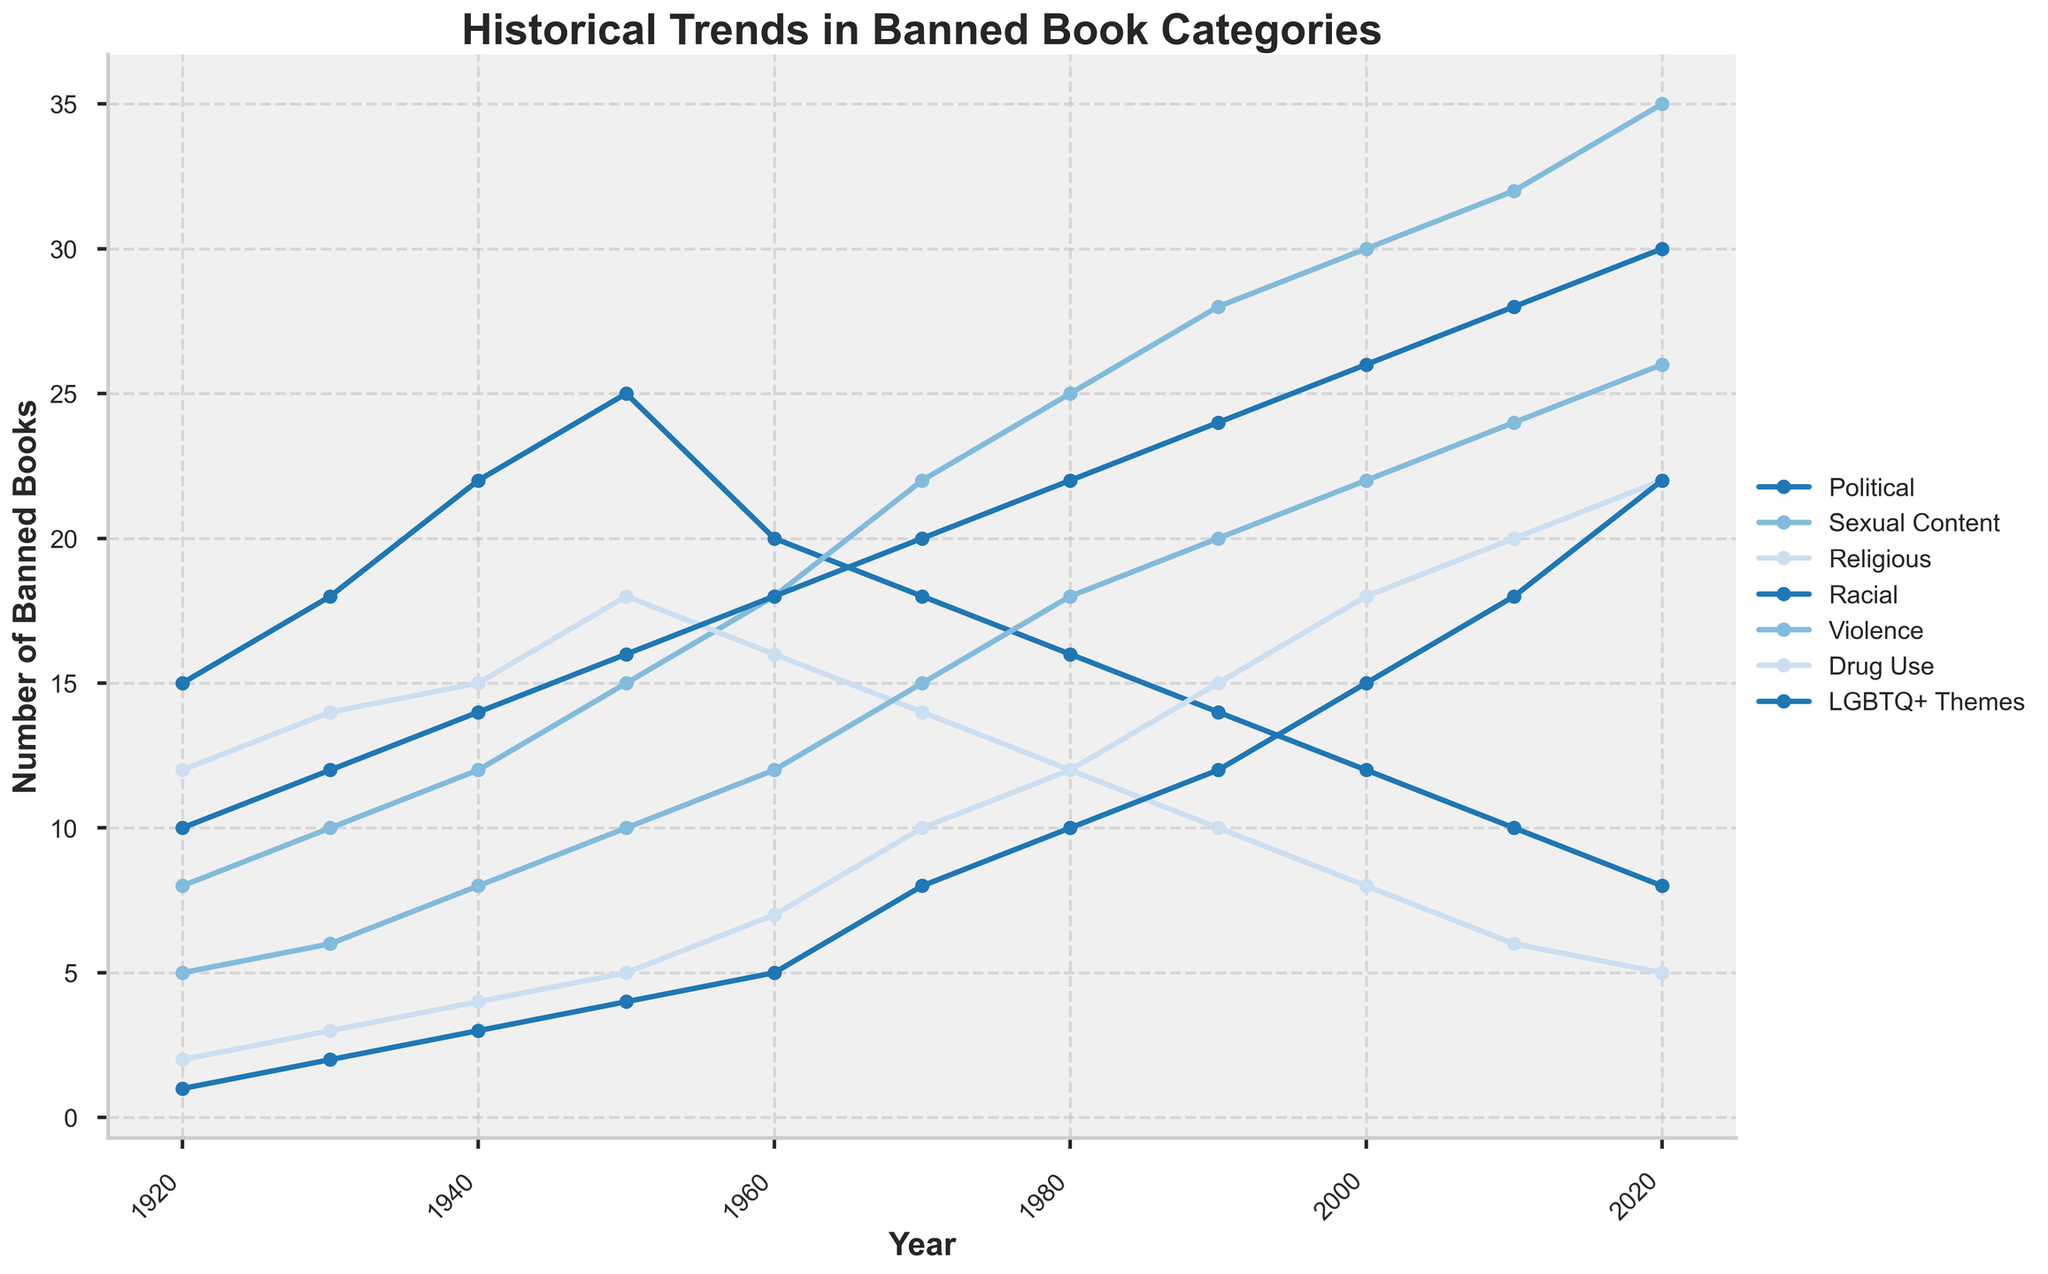How has the number of banned books in the category "Sexual Content" changed from 1920 to 2020? First, observe the value for "Sexual Content" in 1920, which is 8. Then, note the value for 2020, which is 35. The number of banned books has increased by 35 - 8.
Answer: Increased by 27 In which decade did the number of banned books for the category "Political" drop the most compared to the previous decade? Examine the year-over-year changes: 1920 – 15, 1930 – 18, 1940 – 22, 1950 – 25, 1960 – 20, 1970 – 18, 1980 – 16, 1990 – 14, 2000 – 12, 2010 – 10, 2020 – 8. The most significant drop happens between 1950 (25) and 1960 (20), which is 25 - 20.
Answer: 1960s Which category had the highest number of banned books in 1980? Look at the data values for 1980: Political – 16, Sexual Content – 25, Religious – 12, Racial – 22, Violence – 18, Drug Use – 12, LGBTQ+ Themes – 10. The highest value is 25 for "Sexual Content."
Answer: Sexual Content Between which two consecutive decades did the "LGBTQ+ Themes" category see the highest increase in the number of banned books? Calculate the differences between consecutive decades: from 1920 to 1930 (1 to 2), from 1930 to 1940 (2 to 3), from 1940 to 1950 (3 to 4), from 1950 to 1960 (4 to 5), from 1960 to 1970 (5 to 8), from 1970 to 1980 (8 to 10), from 1980 to 1990 (10 to 12), from 1990 to 2000 (12 to 15), from 2000 to 2010 (15 to 18), from 2010 to 2020 (18 to 22). The highest increase occurs between 1960 to 1970 (3).
Answer: 1960 to 1970 In which decade did the category "Religious" experience the lowest number of banned books? Look for the lowest value in the "Religious" category across all decades: 1920 – 12, 1930 – 14, 1940 – 15, 1950 – 18, 1960 – 16, 1970 – 14, 1980 – 12, 1990 – 10, 2000 – 8, 2010 – 6, 2020 – 5. The lowest number is 5 in 2020.
Answer: 2020 What was the sum of the banned books in the categories "Violence" and "Drug Use" in 2020? Look at the values for "Violence" (26) and "Drug Use" (22) in 2020. Add these values together: 26 + 22.
Answer: 48 Which category showed a consistent increase in banned books from 1920 to 2020 without any reductions? Examine each category: 
- Political (varied) 
- Sexual Content (consistent increase) 
- Religious (varied) 
- Racial (varied) 
- Violence (consistent increase) 
- Drug Use (consistent increase) 
- LGBTQ+ Themes (consistent increase)
"Sexual Content," "Violence," "Drug Use," and "LGBTQ+ Themes" consistently increased. Choose one for clarity: "Sexual Content."
Answer: Sexual Content Which category's banned books count was equal to the count of "Racial" banned books in 1950? Compare the counts for 1950: "Political" – 25, "Sexual Content" – 15, "Religious" – 18, "Racial" – 16, "Violence" – 10, "Drug Use" – 5, "LGBTQ+ Themes" – 4. Find the value equal to 16 (Racial).
Answer: Political How did the number of banned books for the "Violence" category change from 1940 to 1970? Check the values for "Violence": 1940 – 8, 1970 – 15. The change is 15 - 8.
Answer: Increased by 7 